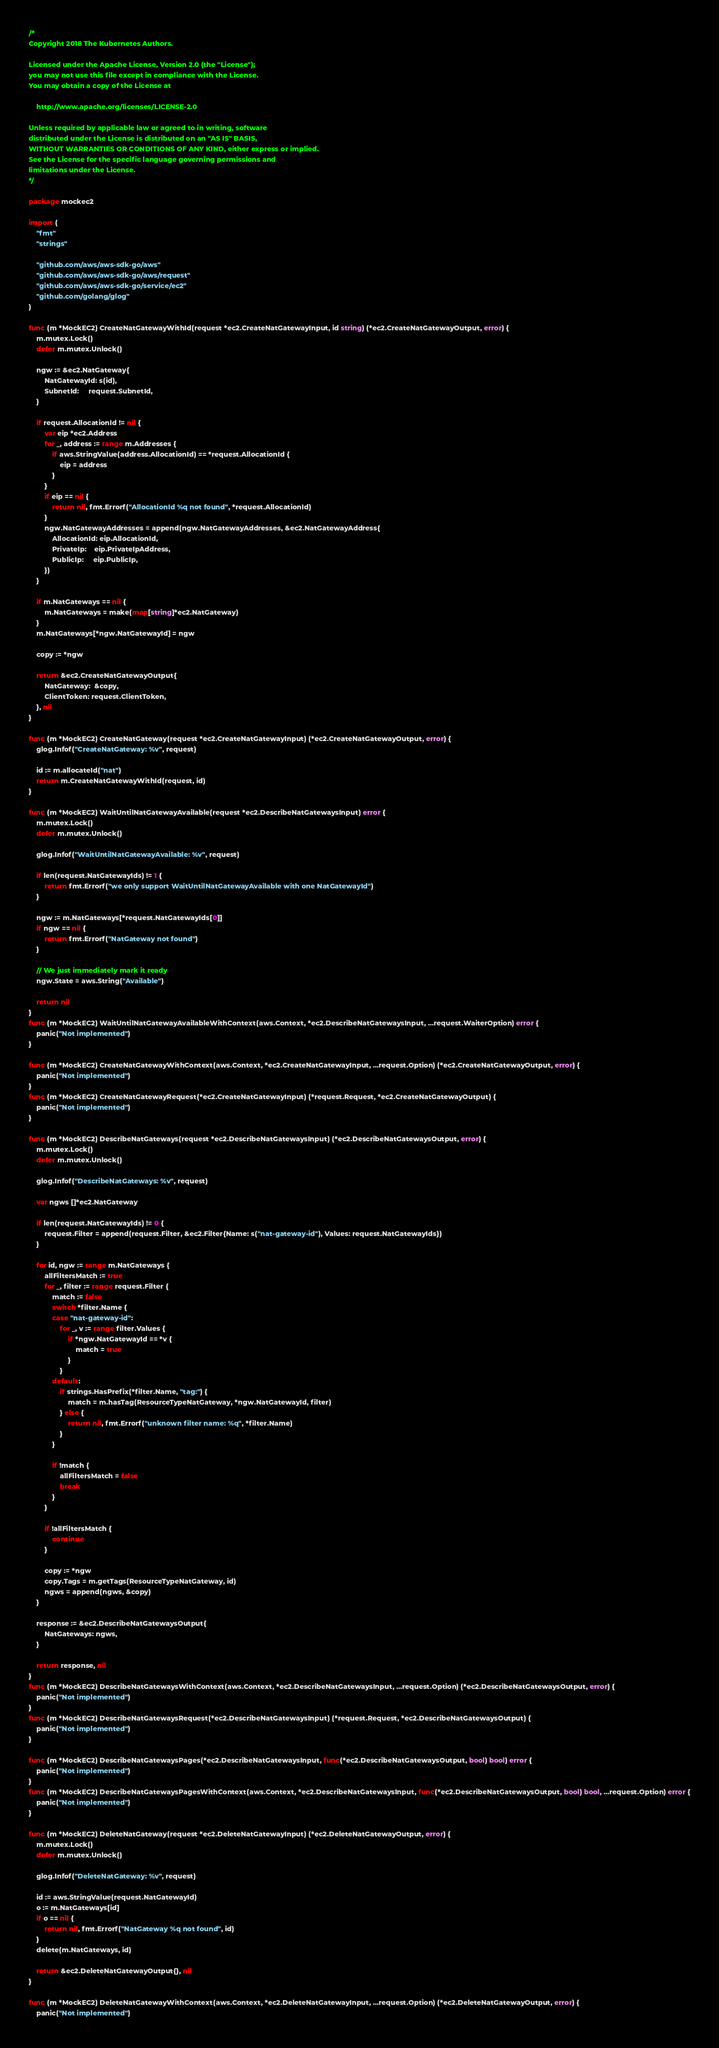<code> <loc_0><loc_0><loc_500><loc_500><_Go_>/*
Copyright 2018 The Kubernetes Authors.

Licensed under the Apache License, Version 2.0 (the "License");
you may not use this file except in compliance with the License.
You may obtain a copy of the License at

    http://www.apache.org/licenses/LICENSE-2.0

Unless required by applicable law or agreed to in writing, software
distributed under the License is distributed on an "AS IS" BASIS,
WITHOUT WARRANTIES OR CONDITIONS OF ANY KIND, either express or implied.
See the License for the specific language governing permissions and
limitations under the License.
*/

package mockec2

import (
	"fmt"
	"strings"

	"github.com/aws/aws-sdk-go/aws"
	"github.com/aws/aws-sdk-go/aws/request"
	"github.com/aws/aws-sdk-go/service/ec2"
	"github.com/golang/glog"
)

func (m *MockEC2) CreateNatGatewayWithId(request *ec2.CreateNatGatewayInput, id string) (*ec2.CreateNatGatewayOutput, error) {
	m.mutex.Lock()
	defer m.mutex.Unlock()

	ngw := &ec2.NatGateway{
		NatGatewayId: s(id),
		SubnetId:     request.SubnetId,
	}

	if request.AllocationId != nil {
		var eip *ec2.Address
		for _, address := range m.Addresses {
			if aws.StringValue(address.AllocationId) == *request.AllocationId {
				eip = address
			}
		}
		if eip == nil {
			return nil, fmt.Errorf("AllocationId %q not found", *request.AllocationId)
		}
		ngw.NatGatewayAddresses = append(ngw.NatGatewayAddresses, &ec2.NatGatewayAddress{
			AllocationId: eip.AllocationId,
			PrivateIp:    eip.PrivateIpAddress,
			PublicIp:     eip.PublicIp,
		})
	}

	if m.NatGateways == nil {
		m.NatGateways = make(map[string]*ec2.NatGateway)
	}
	m.NatGateways[*ngw.NatGatewayId] = ngw

	copy := *ngw

	return &ec2.CreateNatGatewayOutput{
		NatGateway:  &copy,
		ClientToken: request.ClientToken,
	}, nil
}

func (m *MockEC2) CreateNatGateway(request *ec2.CreateNatGatewayInput) (*ec2.CreateNatGatewayOutput, error) {
	glog.Infof("CreateNatGateway: %v", request)

	id := m.allocateId("nat")
	return m.CreateNatGatewayWithId(request, id)
}

func (m *MockEC2) WaitUntilNatGatewayAvailable(request *ec2.DescribeNatGatewaysInput) error {
	m.mutex.Lock()
	defer m.mutex.Unlock()

	glog.Infof("WaitUntilNatGatewayAvailable: %v", request)

	if len(request.NatGatewayIds) != 1 {
		return fmt.Errorf("we only support WaitUntilNatGatewayAvailable with one NatGatewayId")
	}

	ngw := m.NatGateways[*request.NatGatewayIds[0]]
	if ngw == nil {
		return fmt.Errorf("NatGateway not found")
	}

	// We just immediately mark it ready
	ngw.State = aws.String("Available")

	return nil
}
func (m *MockEC2) WaitUntilNatGatewayAvailableWithContext(aws.Context, *ec2.DescribeNatGatewaysInput, ...request.WaiterOption) error {
	panic("Not implemented")
}

func (m *MockEC2) CreateNatGatewayWithContext(aws.Context, *ec2.CreateNatGatewayInput, ...request.Option) (*ec2.CreateNatGatewayOutput, error) {
	panic("Not implemented")
}
func (m *MockEC2) CreateNatGatewayRequest(*ec2.CreateNatGatewayInput) (*request.Request, *ec2.CreateNatGatewayOutput) {
	panic("Not implemented")
}

func (m *MockEC2) DescribeNatGateways(request *ec2.DescribeNatGatewaysInput) (*ec2.DescribeNatGatewaysOutput, error) {
	m.mutex.Lock()
	defer m.mutex.Unlock()

	glog.Infof("DescribeNatGateways: %v", request)

	var ngws []*ec2.NatGateway

	if len(request.NatGatewayIds) != 0 {
		request.Filter = append(request.Filter, &ec2.Filter{Name: s("nat-gateway-id"), Values: request.NatGatewayIds})
	}

	for id, ngw := range m.NatGateways {
		allFiltersMatch := true
		for _, filter := range request.Filter {
			match := false
			switch *filter.Name {
			case "nat-gateway-id":
				for _, v := range filter.Values {
					if *ngw.NatGatewayId == *v {
						match = true
					}
				}
			default:
				if strings.HasPrefix(*filter.Name, "tag:") {
					match = m.hasTag(ResourceTypeNatGateway, *ngw.NatGatewayId, filter)
				} else {
					return nil, fmt.Errorf("unknown filter name: %q", *filter.Name)
				}
			}

			if !match {
				allFiltersMatch = false
				break
			}
		}

		if !allFiltersMatch {
			continue
		}

		copy := *ngw
		copy.Tags = m.getTags(ResourceTypeNatGateway, id)
		ngws = append(ngws, &copy)
	}

	response := &ec2.DescribeNatGatewaysOutput{
		NatGateways: ngws,
	}

	return response, nil
}
func (m *MockEC2) DescribeNatGatewaysWithContext(aws.Context, *ec2.DescribeNatGatewaysInput, ...request.Option) (*ec2.DescribeNatGatewaysOutput, error) {
	panic("Not implemented")
}
func (m *MockEC2) DescribeNatGatewaysRequest(*ec2.DescribeNatGatewaysInput) (*request.Request, *ec2.DescribeNatGatewaysOutput) {
	panic("Not implemented")
}

func (m *MockEC2) DescribeNatGatewaysPages(*ec2.DescribeNatGatewaysInput, func(*ec2.DescribeNatGatewaysOutput, bool) bool) error {
	panic("Not implemented")
}
func (m *MockEC2) DescribeNatGatewaysPagesWithContext(aws.Context, *ec2.DescribeNatGatewaysInput, func(*ec2.DescribeNatGatewaysOutput, bool) bool, ...request.Option) error {
	panic("Not implemented")
}

func (m *MockEC2) DeleteNatGateway(request *ec2.DeleteNatGatewayInput) (*ec2.DeleteNatGatewayOutput, error) {
	m.mutex.Lock()
	defer m.mutex.Unlock()

	glog.Infof("DeleteNatGateway: %v", request)

	id := aws.StringValue(request.NatGatewayId)
	o := m.NatGateways[id]
	if o == nil {
		return nil, fmt.Errorf("NatGateway %q not found", id)
	}
	delete(m.NatGateways, id)

	return &ec2.DeleteNatGatewayOutput{}, nil
}

func (m *MockEC2) DeleteNatGatewayWithContext(aws.Context, *ec2.DeleteNatGatewayInput, ...request.Option) (*ec2.DeleteNatGatewayOutput, error) {
	panic("Not implemented")</code> 